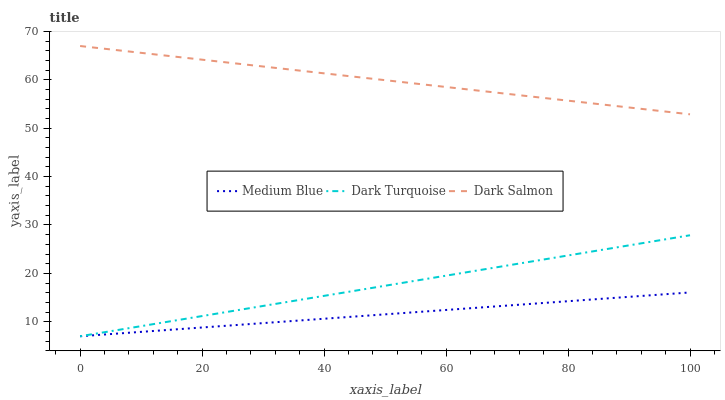Does Medium Blue have the minimum area under the curve?
Answer yes or no. Yes. Does Dark Salmon have the maximum area under the curve?
Answer yes or no. Yes. Does Dark Salmon have the minimum area under the curve?
Answer yes or no. No. Does Medium Blue have the maximum area under the curve?
Answer yes or no. No. Is Dark Turquoise the smoothest?
Answer yes or no. Yes. Is Dark Salmon the roughest?
Answer yes or no. Yes. Is Medium Blue the smoothest?
Answer yes or no. No. Is Medium Blue the roughest?
Answer yes or no. No. Does Dark Turquoise have the lowest value?
Answer yes or no. Yes. Does Dark Salmon have the lowest value?
Answer yes or no. No. Does Dark Salmon have the highest value?
Answer yes or no. Yes. Does Medium Blue have the highest value?
Answer yes or no. No. Is Dark Turquoise less than Dark Salmon?
Answer yes or no. Yes. Is Dark Salmon greater than Medium Blue?
Answer yes or no. Yes. Does Medium Blue intersect Dark Turquoise?
Answer yes or no. Yes. Is Medium Blue less than Dark Turquoise?
Answer yes or no. No. Is Medium Blue greater than Dark Turquoise?
Answer yes or no. No. Does Dark Turquoise intersect Dark Salmon?
Answer yes or no. No. 